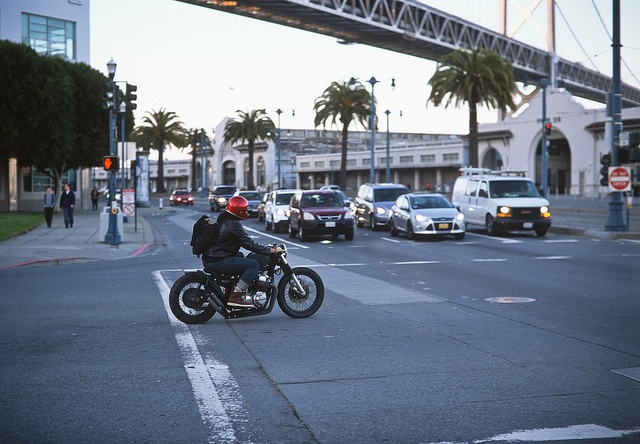Describe the objects in this image and their specific colors. I can see motorcycle in gray and black tones, car in gray, black, lavender, and darkgray tones, car in gray, black, and lavender tones, people in gray, black, and maroon tones, and car in gray, lavender, black, and darkgray tones in this image. 